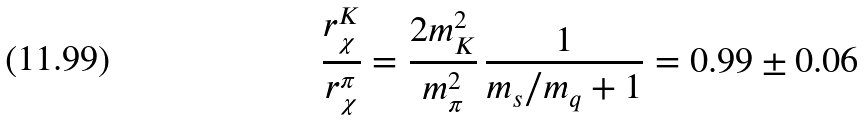Convert formula to latex. <formula><loc_0><loc_0><loc_500><loc_500>\frac { r _ { \chi } ^ { K } } { r _ { \chi } ^ { \pi } } = \frac { 2 m _ { K } ^ { 2 } } { m _ { \pi } ^ { 2 } } \, \frac { 1 } { m _ { s } / m _ { q } + 1 } = 0 . 9 9 \pm 0 . 0 6</formula> 